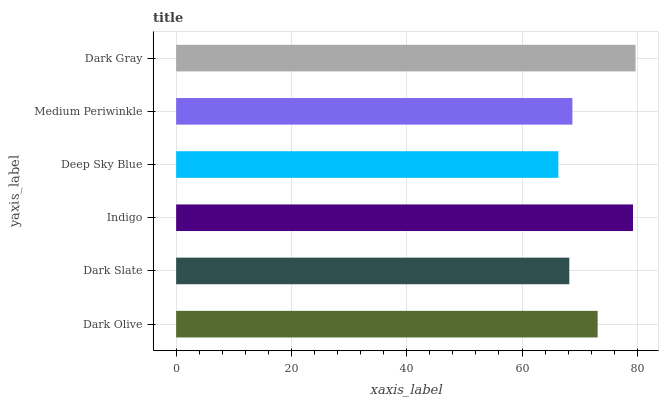Is Deep Sky Blue the minimum?
Answer yes or no. Yes. Is Dark Gray the maximum?
Answer yes or no. Yes. Is Dark Slate the minimum?
Answer yes or no. No. Is Dark Slate the maximum?
Answer yes or no. No. Is Dark Olive greater than Dark Slate?
Answer yes or no. Yes. Is Dark Slate less than Dark Olive?
Answer yes or no. Yes. Is Dark Slate greater than Dark Olive?
Answer yes or no. No. Is Dark Olive less than Dark Slate?
Answer yes or no. No. Is Dark Olive the high median?
Answer yes or no. Yes. Is Medium Periwinkle the low median?
Answer yes or no. Yes. Is Indigo the high median?
Answer yes or no. No. Is Dark Gray the low median?
Answer yes or no. No. 